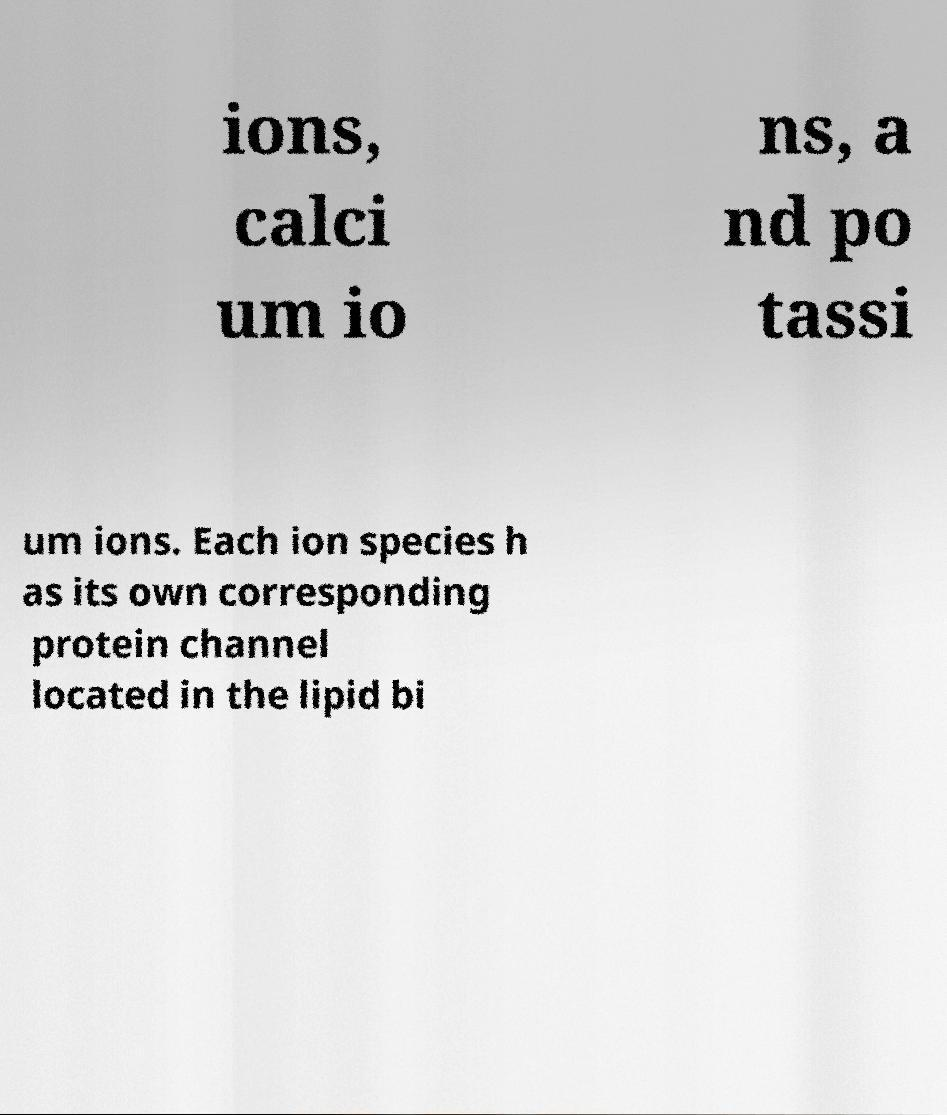Can you read and provide the text displayed in the image?This photo seems to have some interesting text. Can you extract and type it out for me? ions, calci um io ns, a nd po tassi um ions. Each ion species h as its own corresponding protein channel located in the lipid bi 